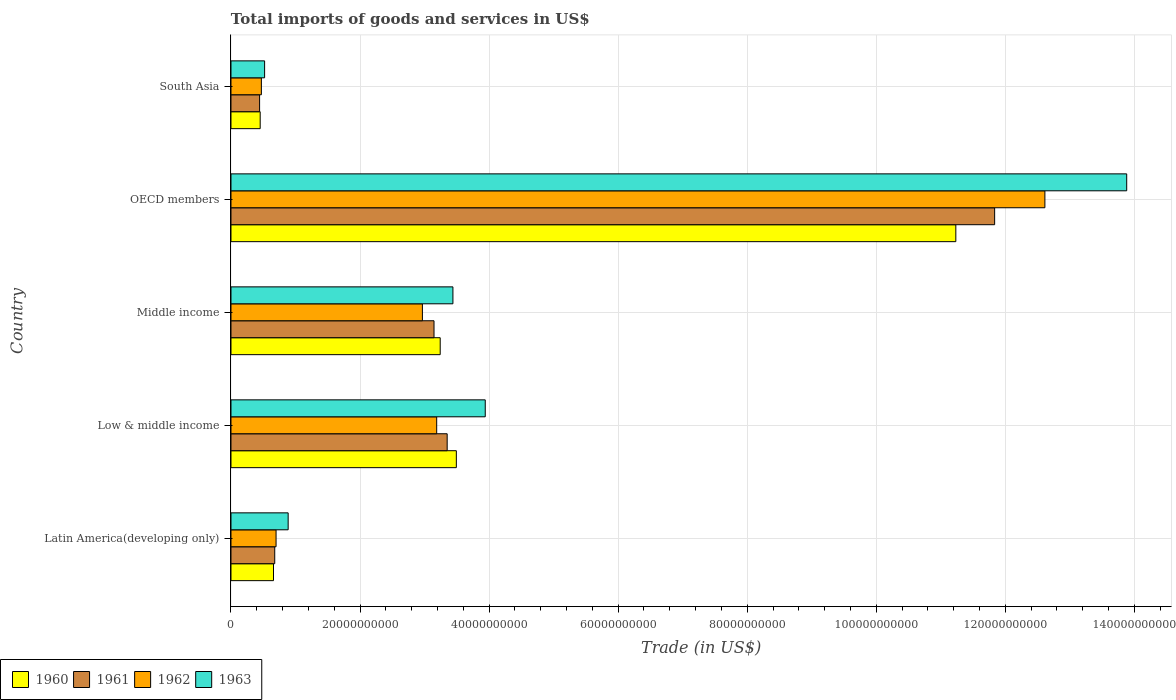How many groups of bars are there?
Provide a succinct answer. 5. What is the label of the 5th group of bars from the top?
Keep it short and to the point. Latin America(developing only). What is the total imports of goods and services in 1962 in South Asia?
Offer a terse response. 4.71e+09. Across all countries, what is the maximum total imports of goods and services in 1962?
Offer a terse response. 1.26e+11. Across all countries, what is the minimum total imports of goods and services in 1962?
Keep it short and to the point. 4.71e+09. In which country was the total imports of goods and services in 1960 minimum?
Ensure brevity in your answer.  South Asia. What is the total total imports of goods and services in 1962 in the graph?
Provide a short and direct response. 1.99e+11. What is the difference between the total imports of goods and services in 1960 in Middle income and that in OECD members?
Make the answer very short. -7.99e+1. What is the difference between the total imports of goods and services in 1961 in Latin America(developing only) and the total imports of goods and services in 1962 in Middle income?
Provide a short and direct response. -2.29e+1. What is the average total imports of goods and services in 1960 per country?
Give a very brief answer. 3.82e+1. What is the difference between the total imports of goods and services in 1962 and total imports of goods and services in 1963 in Latin America(developing only)?
Offer a very short reply. -1.88e+09. In how many countries, is the total imports of goods and services in 1960 greater than 132000000000 US$?
Keep it short and to the point. 0. What is the ratio of the total imports of goods and services in 1960 in Middle income to that in OECD members?
Keep it short and to the point. 0.29. Is the total imports of goods and services in 1963 in Low & middle income less than that in South Asia?
Provide a short and direct response. No. What is the difference between the highest and the second highest total imports of goods and services in 1962?
Your answer should be compact. 9.43e+1. What is the difference between the highest and the lowest total imports of goods and services in 1963?
Provide a succinct answer. 1.34e+11. In how many countries, is the total imports of goods and services in 1961 greater than the average total imports of goods and services in 1961 taken over all countries?
Provide a short and direct response. 1. Is the sum of the total imports of goods and services in 1962 in Low & middle income and OECD members greater than the maximum total imports of goods and services in 1960 across all countries?
Your answer should be very brief. Yes. Is it the case that in every country, the sum of the total imports of goods and services in 1962 and total imports of goods and services in 1960 is greater than the sum of total imports of goods and services in 1963 and total imports of goods and services in 1961?
Your answer should be compact. No. What does the 4th bar from the top in Latin America(developing only) represents?
Make the answer very short. 1960. What does the 1st bar from the bottom in Latin America(developing only) represents?
Offer a terse response. 1960. Is it the case that in every country, the sum of the total imports of goods and services in 1962 and total imports of goods and services in 1960 is greater than the total imports of goods and services in 1961?
Make the answer very short. Yes. How many countries are there in the graph?
Give a very brief answer. 5. Are the values on the major ticks of X-axis written in scientific E-notation?
Provide a short and direct response. No. Where does the legend appear in the graph?
Offer a very short reply. Bottom left. How many legend labels are there?
Offer a terse response. 4. What is the title of the graph?
Offer a terse response. Total imports of goods and services in US$. What is the label or title of the X-axis?
Give a very brief answer. Trade (in US$). What is the Trade (in US$) of 1960 in Latin America(developing only)?
Offer a very short reply. 6.59e+09. What is the Trade (in US$) in 1961 in Latin America(developing only)?
Your answer should be compact. 6.78e+09. What is the Trade (in US$) in 1962 in Latin America(developing only)?
Offer a terse response. 6.99e+09. What is the Trade (in US$) in 1963 in Latin America(developing only)?
Keep it short and to the point. 8.86e+09. What is the Trade (in US$) in 1960 in Low & middle income?
Your answer should be very brief. 3.49e+1. What is the Trade (in US$) of 1961 in Low & middle income?
Offer a terse response. 3.35e+1. What is the Trade (in US$) in 1962 in Low & middle income?
Make the answer very short. 3.19e+1. What is the Trade (in US$) of 1963 in Low & middle income?
Provide a succinct answer. 3.94e+1. What is the Trade (in US$) in 1960 in Middle income?
Give a very brief answer. 3.24e+1. What is the Trade (in US$) of 1961 in Middle income?
Make the answer very short. 3.15e+1. What is the Trade (in US$) of 1962 in Middle income?
Make the answer very short. 2.97e+1. What is the Trade (in US$) of 1963 in Middle income?
Your answer should be very brief. 3.44e+1. What is the Trade (in US$) in 1960 in OECD members?
Make the answer very short. 1.12e+11. What is the Trade (in US$) in 1961 in OECD members?
Provide a short and direct response. 1.18e+11. What is the Trade (in US$) in 1962 in OECD members?
Provide a short and direct response. 1.26e+11. What is the Trade (in US$) of 1963 in OECD members?
Make the answer very short. 1.39e+11. What is the Trade (in US$) in 1960 in South Asia?
Keep it short and to the point. 4.53e+09. What is the Trade (in US$) of 1961 in South Asia?
Offer a terse response. 4.43e+09. What is the Trade (in US$) in 1962 in South Asia?
Make the answer very short. 4.71e+09. What is the Trade (in US$) in 1963 in South Asia?
Your answer should be very brief. 5.21e+09. Across all countries, what is the maximum Trade (in US$) of 1960?
Provide a succinct answer. 1.12e+11. Across all countries, what is the maximum Trade (in US$) of 1961?
Keep it short and to the point. 1.18e+11. Across all countries, what is the maximum Trade (in US$) in 1962?
Your response must be concise. 1.26e+11. Across all countries, what is the maximum Trade (in US$) in 1963?
Ensure brevity in your answer.  1.39e+11. Across all countries, what is the minimum Trade (in US$) in 1960?
Offer a very short reply. 4.53e+09. Across all countries, what is the minimum Trade (in US$) of 1961?
Provide a succinct answer. 4.43e+09. Across all countries, what is the minimum Trade (in US$) of 1962?
Keep it short and to the point. 4.71e+09. Across all countries, what is the minimum Trade (in US$) of 1963?
Offer a terse response. 5.21e+09. What is the total Trade (in US$) of 1960 in the graph?
Offer a terse response. 1.91e+11. What is the total Trade (in US$) of 1961 in the graph?
Your answer should be compact. 1.95e+11. What is the total Trade (in US$) in 1962 in the graph?
Your response must be concise. 1.99e+11. What is the total Trade (in US$) in 1963 in the graph?
Offer a very short reply. 2.27e+11. What is the difference between the Trade (in US$) of 1960 in Latin America(developing only) and that in Low & middle income?
Your answer should be compact. -2.83e+1. What is the difference between the Trade (in US$) of 1961 in Latin America(developing only) and that in Low & middle income?
Offer a very short reply. -2.67e+1. What is the difference between the Trade (in US$) in 1962 in Latin America(developing only) and that in Low & middle income?
Your answer should be compact. -2.49e+1. What is the difference between the Trade (in US$) in 1963 in Latin America(developing only) and that in Low & middle income?
Keep it short and to the point. -3.05e+1. What is the difference between the Trade (in US$) in 1960 in Latin America(developing only) and that in Middle income?
Your answer should be very brief. -2.58e+1. What is the difference between the Trade (in US$) of 1961 in Latin America(developing only) and that in Middle income?
Give a very brief answer. -2.47e+1. What is the difference between the Trade (in US$) in 1962 in Latin America(developing only) and that in Middle income?
Give a very brief answer. -2.27e+1. What is the difference between the Trade (in US$) of 1963 in Latin America(developing only) and that in Middle income?
Offer a terse response. -2.55e+1. What is the difference between the Trade (in US$) of 1960 in Latin America(developing only) and that in OECD members?
Your response must be concise. -1.06e+11. What is the difference between the Trade (in US$) of 1961 in Latin America(developing only) and that in OECD members?
Offer a terse response. -1.12e+11. What is the difference between the Trade (in US$) of 1962 in Latin America(developing only) and that in OECD members?
Provide a succinct answer. -1.19e+11. What is the difference between the Trade (in US$) in 1963 in Latin America(developing only) and that in OECD members?
Make the answer very short. -1.30e+11. What is the difference between the Trade (in US$) of 1960 in Latin America(developing only) and that in South Asia?
Your answer should be very brief. 2.06e+09. What is the difference between the Trade (in US$) in 1961 in Latin America(developing only) and that in South Asia?
Give a very brief answer. 2.35e+09. What is the difference between the Trade (in US$) in 1962 in Latin America(developing only) and that in South Asia?
Give a very brief answer. 2.27e+09. What is the difference between the Trade (in US$) of 1963 in Latin America(developing only) and that in South Asia?
Your answer should be very brief. 3.65e+09. What is the difference between the Trade (in US$) of 1960 in Low & middle income and that in Middle income?
Keep it short and to the point. 2.50e+09. What is the difference between the Trade (in US$) in 1961 in Low & middle income and that in Middle income?
Keep it short and to the point. 2.04e+09. What is the difference between the Trade (in US$) of 1962 in Low & middle income and that in Middle income?
Keep it short and to the point. 2.21e+09. What is the difference between the Trade (in US$) in 1963 in Low & middle income and that in Middle income?
Make the answer very short. 5.01e+09. What is the difference between the Trade (in US$) in 1960 in Low & middle income and that in OECD members?
Offer a terse response. -7.74e+1. What is the difference between the Trade (in US$) in 1961 in Low & middle income and that in OECD members?
Offer a terse response. -8.48e+1. What is the difference between the Trade (in US$) in 1962 in Low & middle income and that in OECD members?
Give a very brief answer. -9.43e+1. What is the difference between the Trade (in US$) of 1963 in Low & middle income and that in OECD members?
Offer a terse response. -9.94e+1. What is the difference between the Trade (in US$) in 1960 in Low & middle income and that in South Asia?
Offer a terse response. 3.04e+1. What is the difference between the Trade (in US$) of 1961 in Low & middle income and that in South Asia?
Ensure brevity in your answer.  2.91e+1. What is the difference between the Trade (in US$) in 1962 in Low & middle income and that in South Asia?
Give a very brief answer. 2.72e+1. What is the difference between the Trade (in US$) in 1963 in Low & middle income and that in South Asia?
Ensure brevity in your answer.  3.42e+1. What is the difference between the Trade (in US$) in 1960 in Middle income and that in OECD members?
Your answer should be very brief. -7.99e+1. What is the difference between the Trade (in US$) of 1961 in Middle income and that in OECD members?
Your response must be concise. -8.69e+1. What is the difference between the Trade (in US$) in 1962 in Middle income and that in OECD members?
Make the answer very short. -9.65e+1. What is the difference between the Trade (in US$) in 1963 in Middle income and that in OECD members?
Offer a terse response. -1.04e+11. What is the difference between the Trade (in US$) in 1960 in Middle income and that in South Asia?
Your answer should be compact. 2.79e+1. What is the difference between the Trade (in US$) in 1961 in Middle income and that in South Asia?
Your response must be concise. 2.70e+1. What is the difference between the Trade (in US$) in 1962 in Middle income and that in South Asia?
Give a very brief answer. 2.50e+1. What is the difference between the Trade (in US$) of 1963 in Middle income and that in South Asia?
Your answer should be compact. 2.92e+1. What is the difference between the Trade (in US$) in 1960 in OECD members and that in South Asia?
Your answer should be compact. 1.08e+11. What is the difference between the Trade (in US$) in 1961 in OECD members and that in South Asia?
Ensure brevity in your answer.  1.14e+11. What is the difference between the Trade (in US$) of 1962 in OECD members and that in South Asia?
Your answer should be compact. 1.21e+11. What is the difference between the Trade (in US$) in 1963 in OECD members and that in South Asia?
Your response must be concise. 1.34e+11. What is the difference between the Trade (in US$) in 1960 in Latin America(developing only) and the Trade (in US$) in 1961 in Low & middle income?
Your answer should be very brief. -2.69e+1. What is the difference between the Trade (in US$) of 1960 in Latin America(developing only) and the Trade (in US$) of 1962 in Low & middle income?
Offer a terse response. -2.53e+1. What is the difference between the Trade (in US$) of 1960 in Latin America(developing only) and the Trade (in US$) of 1963 in Low & middle income?
Your response must be concise. -3.28e+1. What is the difference between the Trade (in US$) of 1961 in Latin America(developing only) and the Trade (in US$) of 1962 in Low & middle income?
Ensure brevity in your answer.  -2.51e+1. What is the difference between the Trade (in US$) in 1961 in Latin America(developing only) and the Trade (in US$) in 1963 in Low & middle income?
Your response must be concise. -3.26e+1. What is the difference between the Trade (in US$) in 1962 in Latin America(developing only) and the Trade (in US$) in 1963 in Low & middle income?
Provide a succinct answer. -3.24e+1. What is the difference between the Trade (in US$) of 1960 in Latin America(developing only) and the Trade (in US$) of 1961 in Middle income?
Provide a short and direct response. -2.49e+1. What is the difference between the Trade (in US$) in 1960 in Latin America(developing only) and the Trade (in US$) in 1962 in Middle income?
Provide a succinct answer. -2.31e+1. What is the difference between the Trade (in US$) in 1960 in Latin America(developing only) and the Trade (in US$) in 1963 in Middle income?
Provide a succinct answer. -2.78e+1. What is the difference between the Trade (in US$) of 1961 in Latin America(developing only) and the Trade (in US$) of 1962 in Middle income?
Give a very brief answer. -2.29e+1. What is the difference between the Trade (in US$) in 1961 in Latin America(developing only) and the Trade (in US$) in 1963 in Middle income?
Offer a terse response. -2.76e+1. What is the difference between the Trade (in US$) of 1962 in Latin America(developing only) and the Trade (in US$) of 1963 in Middle income?
Offer a very short reply. -2.74e+1. What is the difference between the Trade (in US$) of 1960 in Latin America(developing only) and the Trade (in US$) of 1961 in OECD members?
Provide a short and direct response. -1.12e+11. What is the difference between the Trade (in US$) of 1960 in Latin America(developing only) and the Trade (in US$) of 1962 in OECD members?
Your answer should be very brief. -1.20e+11. What is the difference between the Trade (in US$) in 1960 in Latin America(developing only) and the Trade (in US$) in 1963 in OECD members?
Your response must be concise. -1.32e+11. What is the difference between the Trade (in US$) of 1961 in Latin America(developing only) and the Trade (in US$) of 1962 in OECD members?
Your response must be concise. -1.19e+11. What is the difference between the Trade (in US$) of 1961 in Latin America(developing only) and the Trade (in US$) of 1963 in OECD members?
Provide a succinct answer. -1.32e+11. What is the difference between the Trade (in US$) of 1962 in Latin America(developing only) and the Trade (in US$) of 1963 in OECD members?
Your response must be concise. -1.32e+11. What is the difference between the Trade (in US$) of 1960 in Latin America(developing only) and the Trade (in US$) of 1961 in South Asia?
Keep it short and to the point. 2.16e+09. What is the difference between the Trade (in US$) in 1960 in Latin America(developing only) and the Trade (in US$) in 1962 in South Asia?
Give a very brief answer. 1.88e+09. What is the difference between the Trade (in US$) in 1960 in Latin America(developing only) and the Trade (in US$) in 1963 in South Asia?
Provide a short and direct response. 1.38e+09. What is the difference between the Trade (in US$) of 1961 in Latin America(developing only) and the Trade (in US$) of 1962 in South Asia?
Provide a short and direct response. 2.07e+09. What is the difference between the Trade (in US$) in 1961 in Latin America(developing only) and the Trade (in US$) in 1963 in South Asia?
Make the answer very short. 1.57e+09. What is the difference between the Trade (in US$) in 1962 in Latin America(developing only) and the Trade (in US$) in 1963 in South Asia?
Provide a succinct answer. 1.77e+09. What is the difference between the Trade (in US$) of 1960 in Low & middle income and the Trade (in US$) of 1961 in Middle income?
Provide a short and direct response. 3.46e+09. What is the difference between the Trade (in US$) in 1960 in Low & middle income and the Trade (in US$) in 1962 in Middle income?
Make the answer very short. 5.26e+09. What is the difference between the Trade (in US$) of 1960 in Low & middle income and the Trade (in US$) of 1963 in Middle income?
Your answer should be compact. 5.30e+08. What is the difference between the Trade (in US$) of 1961 in Low & middle income and the Trade (in US$) of 1962 in Middle income?
Give a very brief answer. 3.84e+09. What is the difference between the Trade (in US$) of 1961 in Low & middle income and the Trade (in US$) of 1963 in Middle income?
Make the answer very short. -8.90e+08. What is the difference between the Trade (in US$) in 1962 in Low & middle income and the Trade (in US$) in 1963 in Middle income?
Make the answer very short. -2.51e+09. What is the difference between the Trade (in US$) in 1960 in Low & middle income and the Trade (in US$) in 1961 in OECD members?
Provide a succinct answer. -8.34e+1. What is the difference between the Trade (in US$) of 1960 in Low & middle income and the Trade (in US$) of 1962 in OECD members?
Provide a succinct answer. -9.12e+1. What is the difference between the Trade (in US$) of 1960 in Low & middle income and the Trade (in US$) of 1963 in OECD members?
Make the answer very short. -1.04e+11. What is the difference between the Trade (in US$) of 1961 in Low & middle income and the Trade (in US$) of 1962 in OECD members?
Provide a succinct answer. -9.26e+1. What is the difference between the Trade (in US$) in 1961 in Low & middle income and the Trade (in US$) in 1963 in OECD members?
Keep it short and to the point. -1.05e+11. What is the difference between the Trade (in US$) of 1962 in Low & middle income and the Trade (in US$) of 1963 in OECD members?
Your response must be concise. -1.07e+11. What is the difference between the Trade (in US$) in 1960 in Low & middle income and the Trade (in US$) in 1961 in South Asia?
Keep it short and to the point. 3.05e+1. What is the difference between the Trade (in US$) of 1960 in Low & middle income and the Trade (in US$) of 1962 in South Asia?
Your response must be concise. 3.02e+1. What is the difference between the Trade (in US$) in 1960 in Low & middle income and the Trade (in US$) in 1963 in South Asia?
Provide a short and direct response. 2.97e+1. What is the difference between the Trade (in US$) in 1961 in Low & middle income and the Trade (in US$) in 1962 in South Asia?
Your response must be concise. 2.88e+1. What is the difference between the Trade (in US$) of 1961 in Low & middle income and the Trade (in US$) of 1963 in South Asia?
Provide a short and direct response. 2.83e+1. What is the difference between the Trade (in US$) in 1962 in Low & middle income and the Trade (in US$) in 1963 in South Asia?
Your answer should be very brief. 2.67e+1. What is the difference between the Trade (in US$) of 1960 in Middle income and the Trade (in US$) of 1961 in OECD members?
Offer a terse response. -8.59e+1. What is the difference between the Trade (in US$) in 1960 in Middle income and the Trade (in US$) in 1962 in OECD members?
Ensure brevity in your answer.  -9.37e+1. What is the difference between the Trade (in US$) in 1960 in Middle income and the Trade (in US$) in 1963 in OECD members?
Your response must be concise. -1.06e+11. What is the difference between the Trade (in US$) of 1961 in Middle income and the Trade (in US$) of 1962 in OECD members?
Ensure brevity in your answer.  -9.47e+1. What is the difference between the Trade (in US$) of 1961 in Middle income and the Trade (in US$) of 1963 in OECD members?
Offer a terse response. -1.07e+11. What is the difference between the Trade (in US$) of 1962 in Middle income and the Trade (in US$) of 1963 in OECD members?
Offer a terse response. -1.09e+11. What is the difference between the Trade (in US$) in 1960 in Middle income and the Trade (in US$) in 1961 in South Asia?
Ensure brevity in your answer.  2.80e+1. What is the difference between the Trade (in US$) of 1960 in Middle income and the Trade (in US$) of 1962 in South Asia?
Ensure brevity in your answer.  2.77e+1. What is the difference between the Trade (in US$) in 1960 in Middle income and the Trade (in US$) in 1963 in South Asia?
Provide a succinct answer. 2.72e+1. What is the difference between the Trade (in US$) of 1961 in Middle income and the Trade (in US$) of 1962 in South Asia?
Make the answer very short. 2.68e+1. What is the difference between the Trade (in US$) of 1961 in Middle income and the Trade (in US$) of 1963 in South Asia?
Provide a short and direct response. 2.63e+1. What is the difference between the Trade (in US$) of 1962 in Middle income and the Trade (in US$) of 1963 in South Asia?
Your answer should be compact. 2.45e+1. What is the difference between the Trade (in US$) in 1960 in OECD members and the Trade (in US$) in 1961 in South Asia?
Offer a terse response. 1.08e+11. What is the difference between the Trade (in US$) in 1960 in OECD members and the Trade (in US$) in 1962 in South Asia?
Give a very brief answer. 1.08e+11. What is the difference between the Trade (in US$) in 1960 in OECD members and the Trade (in US$) in 1963 in South Asia?
Keep it short and to the point. 1.07e+11. What is the difference between the Trade (in US$) in 1961 in OECD members and the Trade (in US$) in 1962 in South Asia?
Your answer should be very brief. 1.14e+11. What is the difference between the Trade (in US$) of 1961 in OECD members and the Trade (in US$) of 1963 in South Asia?
Your answer should be very brief. 1.13e+11. What is the difference between the Trade (in US$) of 1962 in OECD members and the Trade (in US$) of 1963 in South Asia?
Your answer should be very brief. 1.21e+11. What is the average Trade (in US$) of 1960 per country?
Your response must be concise. 3.82e+1. What is the average Trade (in US$) of 1961 per country?
Make the answer very short. 3.89e+1. What is the average Trade (in US$) in 1962 per country?
Keep it short and to the point. 3.99e+1. What is the average Trade (in US$) of 1963 per country?
Provide a succinct answer. 4.53e+1. What is the difference between the Trade (in US$) of 1960 and Trade (in US$) of 1961 in Latin America(developing only)?
Give a very brief answer. -1.91e+08. What is the difference between the Trade (in US$) in 1960 and Trade (in US$) in 1962 in Latin America(developing only)?
Offer a terse response. -3.96e+08. What is the difference between the Trade (in US$) in 1960 and Trade (in US$) in 1963 in Latin America(developing only)?
Give a very brief answer. -2.27e+09. What is the difference between the Trade (in US$) of 1961 and Trade (in US$) of 1962 in Latin America(developing only)?
Make the answer very short. -2.05e+08. What is the difference between the Trade (in US$) of 1961 and Trade (in US$) of 1963 in Latin America(developing only)?
Provide a succinct answer. -2.08e+09. What is the difference between the Trade (in US$) of 1962 and Trade (in US$) of 1963 in Latin America(developing only)?
Provide a succinct answer. -1.88e+09. What is the difference between the Trade (in US$) of 1960 and Trade (in US$) of 1961 in Low & middle income?
Your response must be concise. 1.42e+09. What is the difference between the Trade (in US$) in 1960 and Trade (in US$) in 1962 in Low & middle income?
Provide a short and direct response. 3.05e+09. What is the difference between the Trade (in US$) of 1960 and Trade (in US$) of 1963 in Low & middle income?
Make the answer very short. -4.48e+09. What is the difference between the Trade (in US$) in 1961 and Trade (in US$) in 1962 in Low & middle income?
Offer a very short reply. 1.62e+09. What is the difference between the Trade (in US$) in 1961 and Trade (in US$) in 1963 in Low & middle income?
Give a very brief answer. -5.90e+09. What is the difference between the Trade (in US$) in 1962 and Trade (in US$) in 1963 in Low & middle income?
Offer a very short reply. -7.52e+09. What is the difference between the Trade (in US$) of 1960 and Trade (in US$) of 1961 in Middle income?
Keep it short and to the point. 9.57e+08. What is the difference between the Trade (in US$) in 1960 and Trade (in US$) in 1962 in Middle income?
Offer a very short reply. 2.76e+09. What is the difference between the Trade (in US$) in 1960 and Trade (in US$) in 1963 in Middle income?
Your response must be concise. -1.97e+09. What is the difference between the Trade (in US$) in 1961 and Trade (in US$) in 1962 in Middle income?
Provide a short and direct response. 1.80e+09. What is the difference between the Trade (in US$) in 1961 and Trade (in US$) in 1963 in Middle income?
Make the answer very short. -2.93e+09. What is the difference between the Trade (in US$) in 1962 and Trade (in US$) in 1963 in Middle income?
Provide a short and direct response. -4.73e+09. What is the difference between the Trade (in US$) of 1960 and Trade (in US$) of 1961 in OECD members?
Provide a short and direct response. -6.01e+09. What is the difference between the Trade (in US$) of 1960 and Trade (in US$) of 1962 in OECD members?
Ensure brevity in your answer.  -1.38e+1. What is the difference between the Trade (in US$) in 1960 and Trade (in US$) in 1963 in OECD members?
Your response must be concise. -2.65e+1. What is the difference between the Trade (in US$) of 1961 and Trade (in US$) of 1962 in OECD members?
Make the answer very short. -7.79e+09. What is the difference between the Trade (in US$) of 1961 and Trade (in US$) of 1963 in OECD members?
Offer a terse response. -2.05e+1. What is the difference between the Trade (in US$) of 1962 and Trade (in US$) of 1963 in OECD members?
Keep it short and to the point. -1.27e+1. What is the difference between the Trade (in US$) of 1960 and Trade (in US$) of 1961 in South Asia?
Offer a terse response. 9.31e+07. What is the difference between the Trade (in US$) of 1960 and Trade (in US$) of 1962 in South Asia?
Make the answer very short. -1.84e+08. What is the difference between the Trade (in US$) of 1960 and Trade (in US$) of 1963 in South Asia?
Offer a terse response. -6.84e+08. What is the difference between the Trade (in US$) of 1961 and Trade (in US$) of 1962 in South Asia?
Offer a terse response. -2.77e+08. What is the difference between the Trade (in US$) of 1961 and Trade (in US$) of 1963 in South Asia?
Offer a terse response. -7.77e+08. What is the difference between the Trade (in US$) in 1962 and Trade (in US$) in 1963 in South Asia?
Offer a terse response. -5.00e+08. What is the ratio of the Trade (in US$) of 1960 in Latin America(developing only) to that in Low & middle income?
Your response must be concise. 0.19. What is the ratio of the Trade (in US$) in 1961 in Latin America(developing only) to that in Low & middle income?
Ensure brevity in your answer.  0.2. What is the ratio of the Trade (in US$) of 1962 in Latin America(developing only) to that in Low & middle income?
Your response must be concise. 0.22. What is the ratio of the Trade (in US$) of 1963 in Latin America(developing only) to that in Low & middle income?
Ensure brevity in your answer.  0.22. What is the ratio of the Trade (in US$) in 1960 in Latin America(developing only) to that in Middle income?
Make the answer very short. 0.2. What is the ratio of the Trade (in US$) of 1961 in Latin America(developing only) to that in Middle income?
Provide a short and direct response. 0.22. What is the ratio of the Trade (in US$) in 1962 in Latin America(developing only) to that in Middle income?
Make the answer very short. 0.24. What is the ratio of the Trade (in US$) of 1963 in Latin America(developing only) to that in Middle income?
Your answer should be compact. 0.26. What is the ratio of the Trade (in US$) of 1960 in Latin America(developing only) to that in OECD members?
Your answer should be compact. 0.06. What is the ratio of the Trade (in US$) in 1961 in Latin America(developing only) to that in OECD members?
Offer a very short reply. 0.06. What is the ratio of the Trade (in US$) of 1962 in Latin America(developing only) to that in OECD members?
Provide a short and direct response. 0.06. What is the ratio of the Trade (in US$) in 1963 in Latin America(developing only) to that in OECD members?
Your answer should be compact. 0.06. What is the ratio of the Trade (in US$) in 1960 in Latin America(developing only) to that in South Asia?
Keep it short and to the point. 1.46. What is the ratio of the Trade (in US$) of 1961 in Latin America(developing only) to that in South Asia?
Ensure brevity in your answer.  1.53. What is the ratio of the Trade (in US$) in 1962 in Latin America(developing only) to that in South Asia?
Make the answer very short. 1.48. What is the ratio of the Trade (in US$) of 1963 in Latin America(developing only) to that in South Asia?
Make the answer very short. 1.7. What is the ratio of the Trade (in US$) of 1960 in Low & middle income to that in Middle income?
Offer a very short reply. 1.08. What is the ratio of the Trade (in US$) of 1961 in Low & middle income to that in Middle income?
Keep it short and to the point. 1.06. What is the ratio of the Trade (in US$) in 1962 in Low & middle income to that in Middle income?
Give a very brief answer. 1.07. What is the ratio of the Trade (in US$) of 1963 in Low & middle income to that in Middle income?
Your answer should be very brief. 1.15. What is the ratio of the Trade (in US$) of 1960 in Low & middle income to that in OECD members?
Make the answer very short. 0.31. What is the ratio of the Trade (in US$) of 1961 in Low & middle income to that in OECD members?
Offer a very short reply. 0.28. What is the ratio of the Trade (in US$) of 1962 in Low & middle income to that in OECD members?
Provide a short and direct response. 0.25. What is the ratio of the Trade (in US$) in 1963 in Low & middle income to that in OECD members?
Ensure brevity in your answer.  0.28. What is the ratio of the Trade (in US$) in 1960 in Low & middle income to that in South Asia?
Your answer should be very brief. 7.71. What is the ratio of the Trade (in US$) in 1961 in Low & middle income to that in South Asia?
Provide a succinct answer. 7.55. What is the ratio of the Trade (in US$) of 1962 in Low & middle income to that in South Asia?
Your answer should be compact. 6.77. What is the ratio of the Trade (in US$) of 1963 in Low & middle income to that in South Asia?
Ensure brevity in your answer.  7.56. What is the ratio of the Trade (in US$) in 1960 in Middle income to that in OECD members?
Provide a succinct answer. 0.29. What is the ratio of the Trade (in US$) in 1961 in Middle income to that in OECD members?
Ensure brevity in your answer.  0.27. What is the ratio of the Trade (in US$) of 1962 in Middle income to that in OECD members?
Keep it short and to the point. 0.24. What is the ratio of the Trade (in US$) in 1963 in Middle income to that in OECD members?
Offer a terse response. 0.25. What is the ratio of the Trade (in US$) of 1960 in Middle income to that in South Asia?
Offer a terse response. 7.16. What is the ratio of the Trade (in US$) of 1961 in Middle income to that in South Asia?
Provide a short and direct response. 7.1. What is the ratio of the Trade (in US$) of 1962 in Middle income to that in South Asia?
Ensure brevity in your answer.  6.3. What is the ratio of the Trade (in US$) in 1963 in Middle income to that in South Asia?
Offer a terse response. 6.6. What is the ratio of the Trade (in US$) of 1960 in OECD members to that in South Asia?
Provide a succinct answer. 24.81. What is the ratio of the Trade (in US$) in 1961 in OECD members to that in South Asia?
Your answer should be compact. 26.69. What is the ratio of the Trade (in US$) in 1962 in OECD members to that in South Asia?
Offer a terse response. 26.77. What is the ratio of the Trade (in US$) in 1963 in OECD members to that in South Asia?
Your response must be concise. 26.63. What is the difference between the highest and the second highest Trade (in US$) of 1960?
Your answer should be compact. 7.74e+1. What is the difference between the highest and the second highest Trade (in US$) in 1961?
Your answer should be very brief. 8.48e+1. What is the difference between the highest and the second highest Trade (in US$) in 1962?
Give a very brief answer. 9.43e+1. What is the difference between the highest and the second highest Trade (in US$) in 1963?
Offer a very short reply. 9.94e+1. What is the difference between the highest and the lowest Trade (in US$) of 1960?
Keep it short and to the point. 1.08e+11. What is the difference between the highest and the lowest Trade (in US$) in 1961?
Provide a succinct answer. 1.14e+11. What is the difference between the highest and the lowest Trade (in US$) of 1962?
Give a very brief answer. 1.21e+11. What is the difference between the highest and the lowest Trade (in US$) of 1963?
Provide a succinct answer. 1.34e+11. 